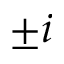Convert formula to latex. <formula><loc_0><loc_0><loc_500><loc_500>\pm i</formula> 